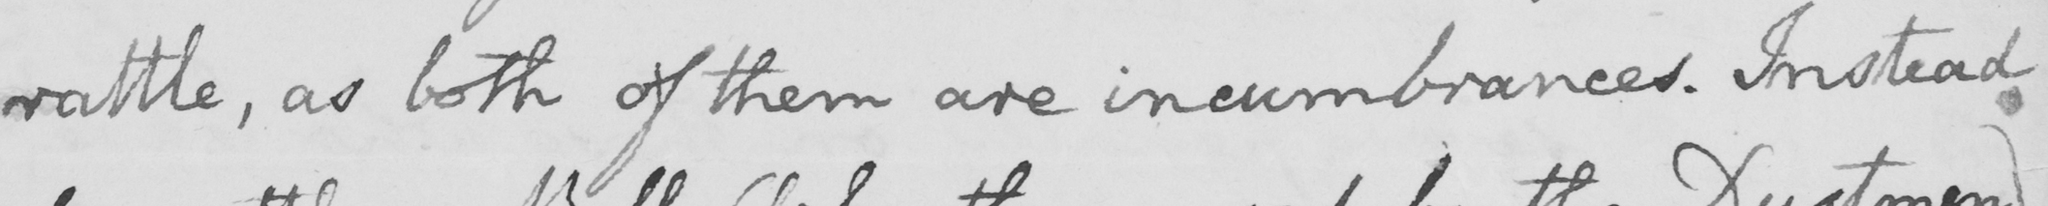What is written in this line of handwriting? rattle , as both of them are incumbrances . Instead 